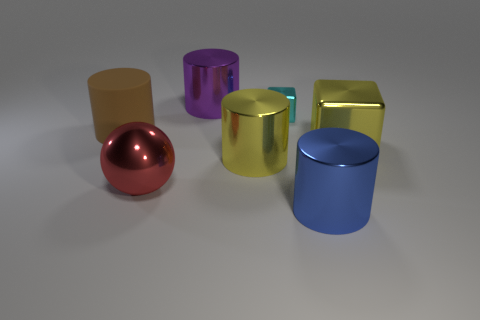There is a cyan object that is the same material as the big red thing; what is its size?
Your answer should be very brief. Small. What is the red ball made of?
Offer a very short reply. Metal. How many yellow shiny cylinders have the same size as the yellow cube?
Your answer should be compact. 1. The metal object that is the same color as the big cube is what shape?
Your answer should be very brief. Cylinder. Is there a yellow thing of the same shape as the big blue object?
Provide a short and direct response. Yes. There is a matte cylinder that is the same size as the yellow cube; what is its color?
Your answer should be compact. Brown. There is a large cylinder that is left of the big red ball that is in front of the big brown rubber cylinder; what color is it?
Offer a very short reply. Brown. The red shiny thing on the left side of the block that is to the right of the large thing that is in front of the red thing is what shape?
Your answer should be very brief. Sphere. There is a metal cylinder that is in front of the large metallic sphere; how many purple cylinders are right of it?
Make the answer very short. 0. Is the material of the big yellow cylinder the same as the large blue cylinder?
Offer a very short reply. Yes. 